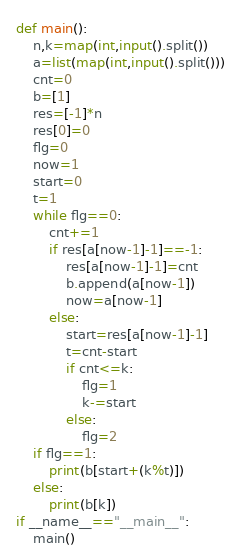<code> <loc_0><loc_0><loc_500><loc_500><_Python_>def main():
    n,k=map(int,input().split())
    a=list(map(int,input().split()))
    cnt=0
    b=[1]
    res=[-1]*n
    res[0]=0
    flg=0
    now=1
    start=0
    t=1
    while flg==0:
        cnt+=1
        if res[a[now-1]-1]==-1:
            res[a[now-1]-1]=cnt
            b.append(a[now-1])
            now=a[now-1]
        else:
            start=res[a[now-1]-1]
            t=cnt-start
            if cnt<=k:
                flg=1
                k-=start
            else:
                flg=2
    if flg==1:
        print(b[start+(k%t)])
    else:
        print(b[k])
if __name__=="__main__":
    main()</code> 